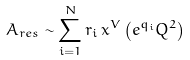<formula> <loc_0><loc_0><loc_500><loc_500>A _ { r e s } \sim \sum _ { i = 1 } ^ { N } r _ { i } \, x ^ { V } \left ( e ^ { q _ { i } } Q ^ { 2 } \right )</formula> 